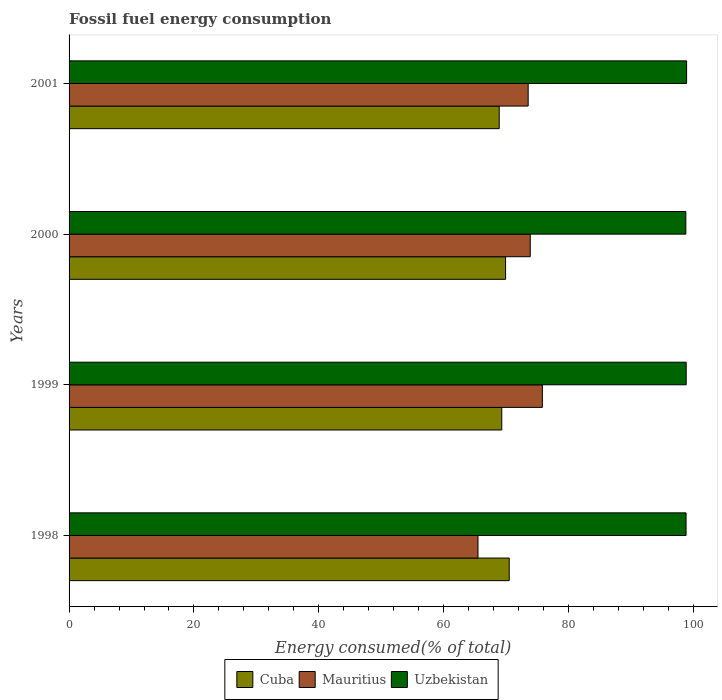How many different coloured bars are there?
Provide a succinct answer. 3. How many bars are there on the 2nd tick from the top?
Make the answer very short. 3. How many bars are there on the 1st tick from the bottom?
Give a very brief answer. 3. In how many cases, is the number of bars for a given year not equal to the number of legend labels?
Provide a succinct answer. 0. What is the percentage of energy consumed in Cuba in 1998?
Give a very brief answer. 70.49. Across all years, what is the maximum percentage of energy consumed in Uzbekistan?
Provide a succinct answer. 98.91. Across all years, what is the minimum percentage of energy consumed in Mauritius?
Give a very brief answer. 65.49. What is the total percentage of energy consumed in Mauritius in the graph?
Make the answer very short. 288.68. What is the difference between the percentage of energy consumed in Uzbekistan in 2000 and that in 2001?
Provide a short and direct response. -0.13. What is the difference between the percentage of energy consumed in Mauritius in 2000 and the percentage of energy consumed in Cuba in 2001?
Offer a terse response. 4.97. What is the average percentage of energy consumed in Uzbekistan per year?
Give a very brief answer. 98.83. In the year 2000, what is the difference between the percentage of energy consumed in Uzbekistan and percentage of energy consumed in Mauritius?
Your answer should be compact. 24.92. In how many years, is the percentage of energy consumed in Cuba greater than 72 %?
Make the answer very short. 0. What is the ratio of the percentage of energy consumed in Cuba in 1999 to that in 2001?
Your answer should be compact. 1.01. Is the difference between the percentage of energy consumed in Uzbekistan in 1998 and 2001 greater than the difference between the percentage of energy consumed in Mauritius in 1998 and 2001?
Provide a short and direct response. Yes. What is the difference between the highest and the second highest percentage of energy consumed in Cuba?
Your answer should be very brief. 0.58. What is the difference between the highest and the lowest percentage of energy consumed in Mauritius?
Give a very brief answer. 10.31. Is the sum of the percentage of energy consumed in Cuba in 1999 and 2000 greater than the maximum percentage of energy consumed in Uzbekistan across all years?
Your answer should be compact. Yes. What does the 3rd bar from the top in 2001 represents?
Provide a short and direct response. Cuba. What does the 3rd bar from the bottom in 2000 represents?
Give a very brief answer. Uzbekistan. Is it the case that in every year, the sum of the percentage of energy consumed in Uzbekistan and percentage of energy consumed in Cuba is greater than the percentage of energy consumed in Mauritius?
Keep it short and to the point. Yes. Are the values on the major ticks of X-axis written in scientific E-notation?
Your answer should be compact. No. Does the graph contain any zero values?
Give a very brief answer. No. What is the title of the graph?
Ensure brevity in your answer.  Fossil fuel energy consumption. What is the label or title of the X-axis?
Provide a succinct answer. Energy consumed(% of total). What is the label or title of the Y-axis?
Your response must be concise. Years. What is the Energy consumed(% of total) in Cuba in 1998?
Your answer should be compact. 70.49. What is the Energy consumed(% of total) in Mauritius in 1998?
Your answer should be compact. 65.49. What is the Energy consumed(% of total) in Uzbekistan in 1998?
Offer a very short reply. 98.82. What is the Energy consumed(% of total) in Cuba in 1999?
Your response must be concise. 69.3. What is the Energy consumed(% of total) of Mauritius in 1999?
Your answer should be very brief. 75.8. What is the Energy consumed(% of total) of Uzbekistan in 1999?
Provide a succinct answer. 98.84. What is the Energy consumed(% of total) of Cuba in 2000?
Give a very brief answer. 69.91. What is the Energy consumed(% of total) in Mauritius in 2000?
Keep it short and to the point. 73.86. What is the Energy consumed(% of total) in Uzbekistan in 2000?
Your response must be concise. 98.78. What is the Energy consumed(% of total) of Cuba in 2001?
Give a very brief answer. 68.89. What is the Energy consumed(% of total) in Mauritius in 2001?
Make the answer very short. 73.53. What is the Energy consumed(% of total) of Uzbekistan in 2001?
Keep it short and to the point. 98.91. Across all years, what is the maximum Energy consumed(% of total) in Cuba?
Offer a terse response. 70.49. Across all years, what is the maximum Energy consumed(% of total) of Mauritius?
Make the answer very short. 75.8. Across all years, what is the maximum Energy consumed(% of total) in Uzbekistan?
Offer a very short reply. 98.91. Across all years, what is the minimum Energy consumed(% of total) in Cuba?
Provide a succinct answer. 68.89. Across all years, what is the minimum Energy consumed(% of total) in Mauritius?
Ensure brevity in your answer.  65.49. Across all years, what is the minimum Energy consumed(% of total) in Uzbekistan?
Make the answer very short. 98.78. What is the total Energy consumed(% of total) in Cuba in the graph?
Provide a short and direct response. 278.6. What is the total Energy consumed(% of total) in Mauritius in the graph?
Ensure brevity in your answer.  288.68. What is the total Energy consumed(% of total) of Uzbekistan in the graph?
Give a very brief answer. 395.34. What is the difference between the Energy consumed(% of total) in Cuba in 1998 and that in 1999?
Offer a terse response. 1.19. What is the difference between the Energy consumed(% of total) of Mauritius in 1998 and that in 1999?
Make the answer very short. -10.31. What is the difference between the Energy consumed(% of total) of Uzbekistan in 1998 and that in 1999?
Offer a terse response. -0.02. What is the difference between the Energy consumed(% of total) in Cuba in 1998 and that in 2000?
Offer a very short reply. 0.58. What is the difference between the Energy consumed(% of total) of Mauritius in 1998 and that in 2000?
Ensure brevity in your answer.  -8.37. What is the difference between the Energy consumed(% of total) of Uzbekistan in 1998 and that in 2000?
Give a very brief answer. 0.04. What is the difference between the Energy consumed(% of total) in Cuba in 1998 and that in 2001?
Ensure brevity in your answer.  1.6. What is the difference between the Energy consumed(% of total) of Mauritius in 1998 and that in 2001?
Offer a very short reply. -8.04. What is the difference between the Energy consumed(% of total) in Uzbekistan in 1998 and that in 2001?
Your response must be concise. -0.09. What is the difference between the Energy consumed(% of total) in Cuba in 1999 and that in 2000?
Provide a short and direct response. -0.61. What is the difference between the Energy consumed(% of total) in Mauritius in 1999 and that in 2000?
Ensure brevity in your answer.  1.94. What is the difference between the Energy consumed(% of total) of Uzbekistan in 1999 and that in 2000?
Provide a succinct answer. 0.06. What is the difference between the Energy consumed(% of total) of Cuba in 1999 and that in 2001?
Provide a short and direct response. 0.41. What is the difference between the Energy consumed(% of total) of Mauritius in 1999 and that in 2001?
Make the answer very short. 2.27. What is the difference between the Energy consumed(% of total) of Uzbekistan in 1999 and that in 2001?
Ensure brevity in your answer.  -0.07. What is the difference between the Energy consumed(% of total) in Cuba in 2000 and that in 2001?
Your answer should be compact. 1.02. What is the difference between the Energy consumed(% of total) of Mauritius in 2000 and that in 2001?
Ensure brevity in your answer.  0.34. What is the difference between the Energy consumed(% of total) of Uzbekistan in 2000 and that in 2001?
Keep it short and to the point. -0.13. What is the difference between the Energy consumed(% of total) of Cuba in 1998 and the Energy consumed(% of total) of Mauritius in 1999?
Your response must be concise. -5.31. What is the difference between the Energy consumed(% of total) in Cuba in 1998 and the Energy consumed(% of total) in Uzbekistan in 1999?
Offer a terse response. -28.34. What is the difference between the Energy consumed(% of total) in Mauritius in 1998 and the Energy consumed(% of total) in Uzbekistan in 1999?
Offer a terse response. -33.35. What is the difference between the Energy consumed(% of total) of Cuba in 1998 and the Energy consumed(% of total) of Mauritius in 2000?
Your answer should be compact. -3.37. What is the difference between the Energy consumed(% of total) of Cuba in 1998 and the Energy consumed(% of total) of Uzbekistan in 2000?
Provide a short and direct response. -28.29. What is the difference between the Energy consumed(% of total) of Mauritius in 1998 and the Energy consumed(% of total) of Uzbekistan in 2000?
Keep it short and to the point. -33.29. What is the difference between the Energy consumed(% of total) in Cuba in 1998 and the Energy consumed(% of total) in Mauritius in 2001?
Your response must be concise. -3.03. What is the difference between the Energy consumed(% of total) in Cuba in 1998 and the Energy consumed(% of total) in Uzbekistan in 2001?
Provide a succinct answer. -28.41. What is the difference between the Energy consumed(% of total) in Mauritius in 1998 and the Energy consumed(% of total) in Uzbekistan in 2001?
Keep it short and to the point. -33.41. What is the difference between the Energy consumed(% of total) in Cuba in 1999 and the Energy consumed(% of total) in Mauritius in 2000?
Give a very brief answer. -4.56. What is the difference between the Energy consumed(% of total) in Cuba in 1999 and the Energy consumed(% of total) in Uzbekistan in 2000?
Offer a very short reply. -29.48. What is the difference between the Energy consumed(% of total) of Mauritius in 1999 and the Energy consumed(% of total) of Uzbekistan in 2000?
Ensure brevity in your answer.  -22.98. What is the difference between the Energy consumed(% of total) of Cuba in 1999 and the Energy consumed(% of total) of Mauritius in 2001?
Your answer should be very brief. -4.23. What is the difference between the Energy consumed(% of total) in Cuba in 1999 and the Energy consumed(% of total) in Uzbekistan in 2001?
Your answer should be very brief. -29.6. What is the difference between the Energy consumed(% of total) in Mauritius in 1999 and the Energy consumed(% of total) in Uzbekistan in 2001?
Your response must be concise. -23.1. What is the difference between the Energy consumed(% of total) of Cuba in 2000 and the Energy consumed(% of total) of Mauritius in 2001?
Provide a succinct answer. -3.62. What is the difference between the Energy consumed(% of total) in Cuba in 2000 and the Energy consumed(% of total) in Uzbekistan in 2001?
Make the answer very short. -28.99. What is the difference between the Energy consumed(% of total) of Mauritius in 2000 and the Energy consumed(% of total) of Uzbekistan in 2001?
Make the answer very short. -25.04. What is the average Energy consumed(% of total) of Cuba per year?
Your answer should be very brief. 69.65. What is the average Energy consumed(% of total) in Mauritius per year?
Your answer should be very brief. 72.17. What is the average Energy consumed(% of total) of Uzbekistan per year?
Provide a short and direct response. 98.83. In the year 1998, what is the difference between the Energy consumed(% of total) in Cuba and Energy consumed(% of total) in Mauritius?
Make the answer very short. 5. In the year 1998, what is the difference between the Energy consumed(% of total) of Cuba and Energy consumed(% of total) of Uzbekistan?
Your answer should be compact. -28.32. In the year 1998, what is the difference between the Energy consumed(% of total) in Mauritius and Energy consumed(% of total) in Uzbekistan?
Give a very brief answer. -33.32. In the year 1999, what is the difference between the Energy consumed(% of total) in Cuba and Energy consumed(% of total) in Mauritius?
Keep it short and to the point. -6.5. In the year 1999, what is the difference between the Energy consumed(% of total) in Cuba and Energy consumed(% of total) in Uzbekistan?
Offer a terse response. -29.54. In the year 1999, what is the difference between the Energy consumed(% of total) of Mauritius and Energy consumed(% of total) of Uzbekistan?
Keep it short and to the point. -23.04. In the year 2000, what is the difference between the Energy consumed(% of total) in Cuba and Energy consumed(% of total) in Mauritius?
Your answer should be compact. -3.95. In the year 2000, what is the difference between the Energy consumed(% of total) of Cuba and Energy consumed(% of total) of Uzbekistan?
Your response must be concise. -28.87. In the year 2000, what is the difference between the Energy consumed(% of total) in Mauritius and Energy consumed(% of total) in Uzbekistan?
Give a very brief answer. -24.92. In the year 2001, what is the difference between the Energy consumed(% of total) in Cuba and Energy consumed(% of total) in Mauritius?
Your answer should be compact. -4.64. In the year 2001, what is the difference between the Energy consumed(% of total) of Cuba and Energy consumed(% of total) of Uzbekistan?
Provide a short and direct response. -30.01. In the year 2001, what is the difference between the Energy consumed(% of total) of Mauritius and Energy consumed(% of total) of Uzbekistan?
Provide a short and direct response. -25.38. What is the ratio of the Energy consumed(% of total) in Cuba in 1998 to that in 1999?
Your response must be concise. 1.02. What is the ratio of the Energy consumed(% of total) in Mauritius in 1998 to that in 1999?
Make the answer very short. 0.86. What is the ratio of the Energy consumed(% of total) of Uzbekistan in 1998 to that in 1999?
Your answer should be compact. 1. What is the ratio of the Energy consumed(% of total) of Cuba in 1998 to that in 2000?
Provide a succinct answer. 1.01. What is the ratio of the Energy consumed(% of total) in Mauritius in 1998 to that in 2000?
Your answer should be very brief. 0.89. What is the ratio of the Energy consumed(% of total) in Cuba in 1998 to that in 2001?
Provide a short and direct response. 1.02. What is the ratio of the Energy consumed(% of total) in Mauritius in 1998 to that in 2001?
Your answer should be very brief. 0.89. What is the ratio of the Energy consumed(% of total) in Uzbekistan in 1998 to that in 2001?
Offer a terse response. 1. What is the ratio of the Energy consumed(% of total) of Mauritius in 1999 to that in 2000?
Ensure brevity in your answer.  1.03. What is the ratio of the Energy consumed(% of total) of Cuba in 1999 to that in 2001?
Provide a succinct answer. 1.01. What is the ratio of the Energy consumed(% of total) in Mauritius in 1999 to that in 2001?
Keep it short and to the point. 1.03. What is the ratio of the Energy consumed(% of total) of Uzbekistan in 1999 to that in 2001?
Provide a short and direct response. 1. What is the ratio of the Energy consumed(% of total) of Cuba in 2000 to that in 2001?
Ensure brevity in your answer.  1.01. What is the ratio of the Energy consumed(% of total) in Mauritius in 2000 to that in 2001?
Give a very brief answer. 1. What is the ratio of the Energy consumed(% of total) in Uzbekistan in 2000 to that in 2001?
Your answer should be compact. 1. What is the difference between the highest and the second highest Energy consumed(% of total) of Cuba?
Offer a very short reply. 0.58. What is the difference between the highest and the second highest Energy consumed(% of total) in Mauritius?
Ensure brevity in your answer.  1.94. What is the difference between the highest and the second highest Energy consumed(% of total) in Uzbekistan?
Give a very brief answer. 0.07. What is the difference between the highest and the lowest Energy consumed(% of total) in Cuba?
Your response must be concise. 1.6. What is the difference between the highest and the lowest Energy consumed(% of total) of Mauritius?
Ensure brevity in your answer.  10.31. What is the difference between the highest and the lowest Energy consumed(% of total) in Uzbekistan?
Offer a very short reply. 0.13. 